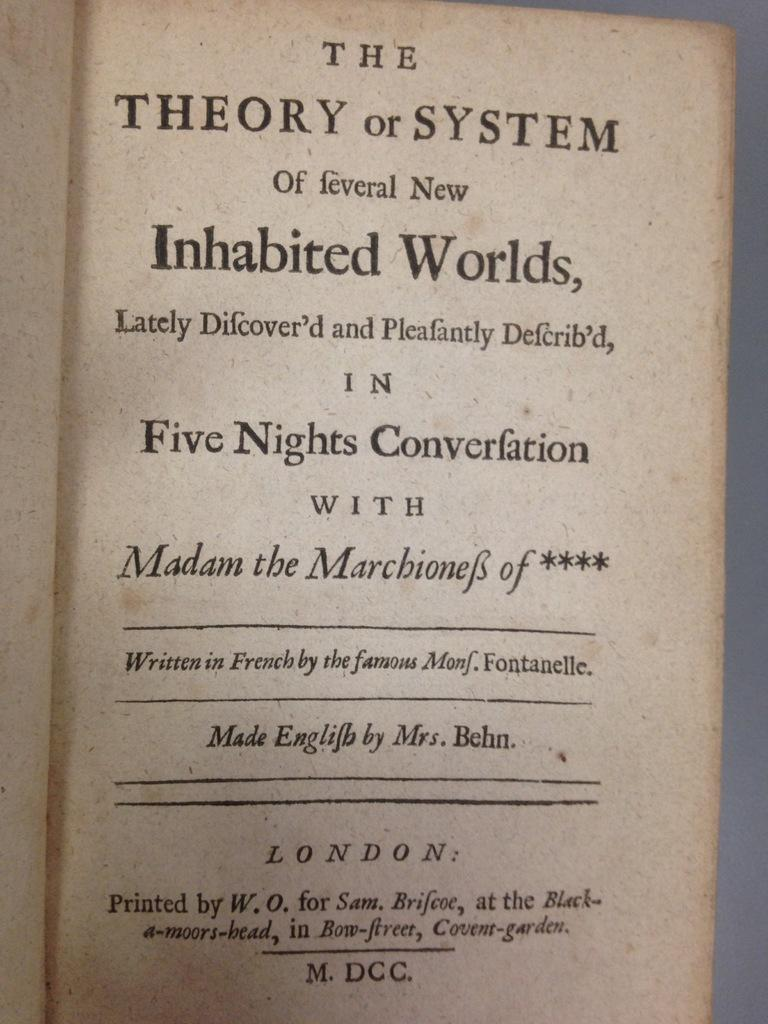Provide a one-sentence caption for the provided image. A title page of the book called The Theory or System of Feveral New Inhabited Worlds. 